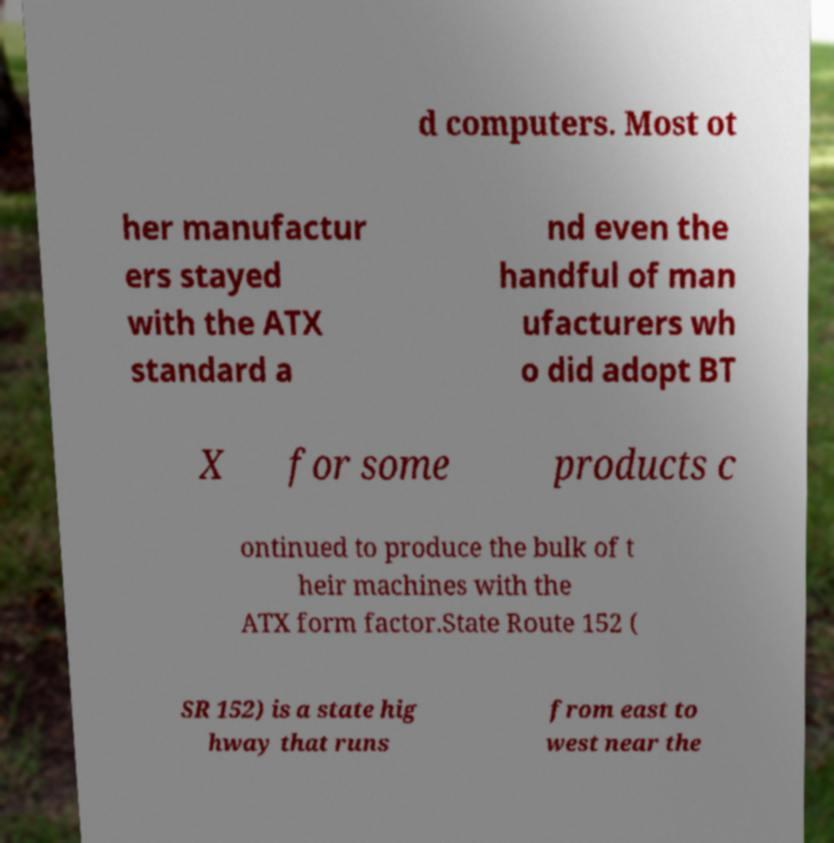I need the written content from this picture converted into text. Can you do that? d computers. Most ot her manufactur ers stayed with the ATX standard a nd even the handful of man ufacturers wh o did adopt BT X for some products c ontinued to produce the bulk of t heir machines with the ATX form factor.State Route 152 ( SR 152) is a state hig hway that runs from east to west near the 